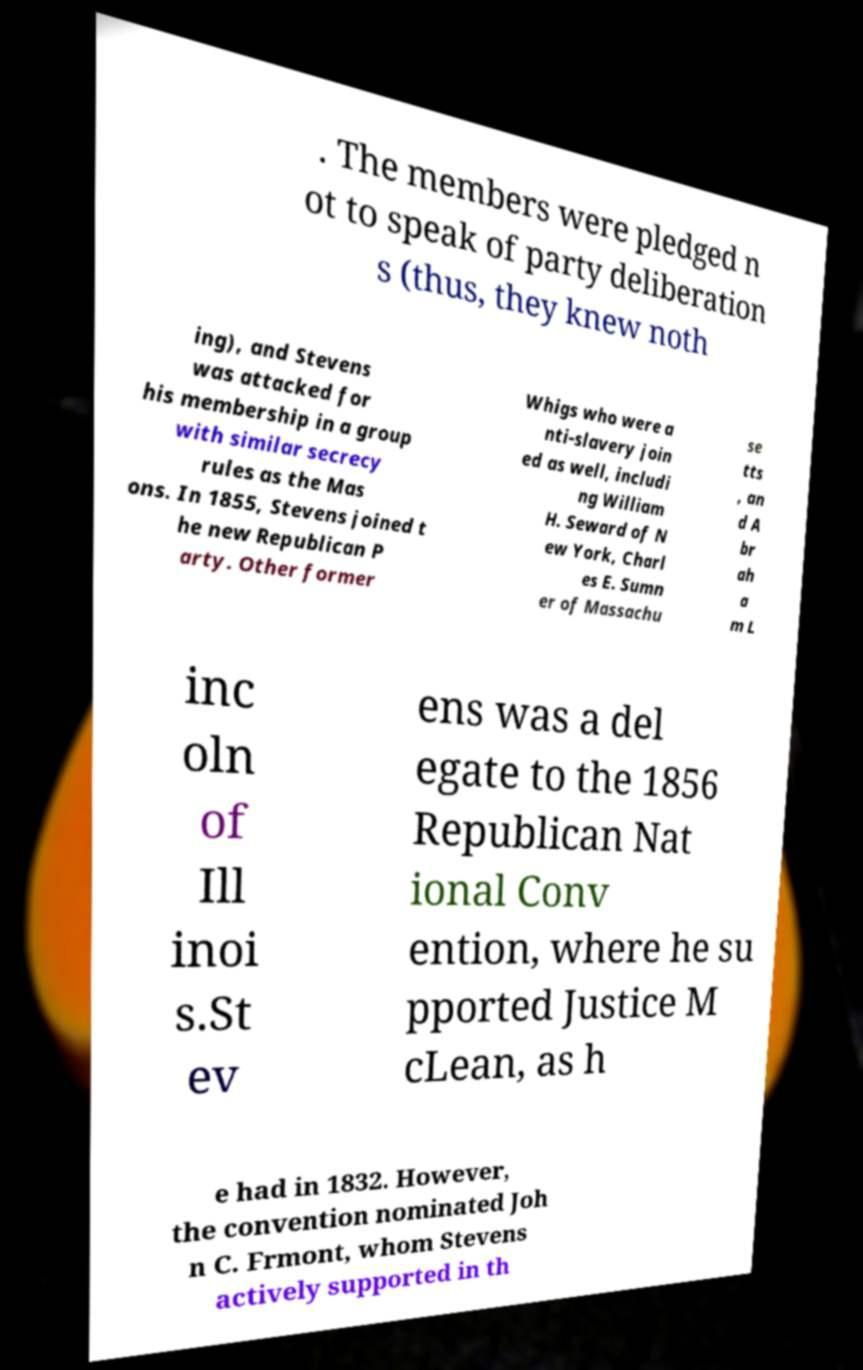I need the written content from this picture converted into text. Can you do that? . The members were pledged n ot to speak of party deliberation s (thus, they knew noth ing), and Stevens was attacked for his membership in a group with similar secrecy rules as the Mas ons. In 1855, Stevens joined t he new Republican P arty. Other former Whigs who were a nti-slavery join ed as well, includi ng William H. Seward of N ew York, Charl es E. Sumn er of Massachu se tts , an d A br ah a m L inc oln of Ill inoi s.St ev ens was a del egate to the 1856 Republican Nat ional Conv ention, where he su pported Justice M cLean, as h e had in 1832. However, the convention nominated Joh n C. Frmont, whom Stevens actively supported in th 